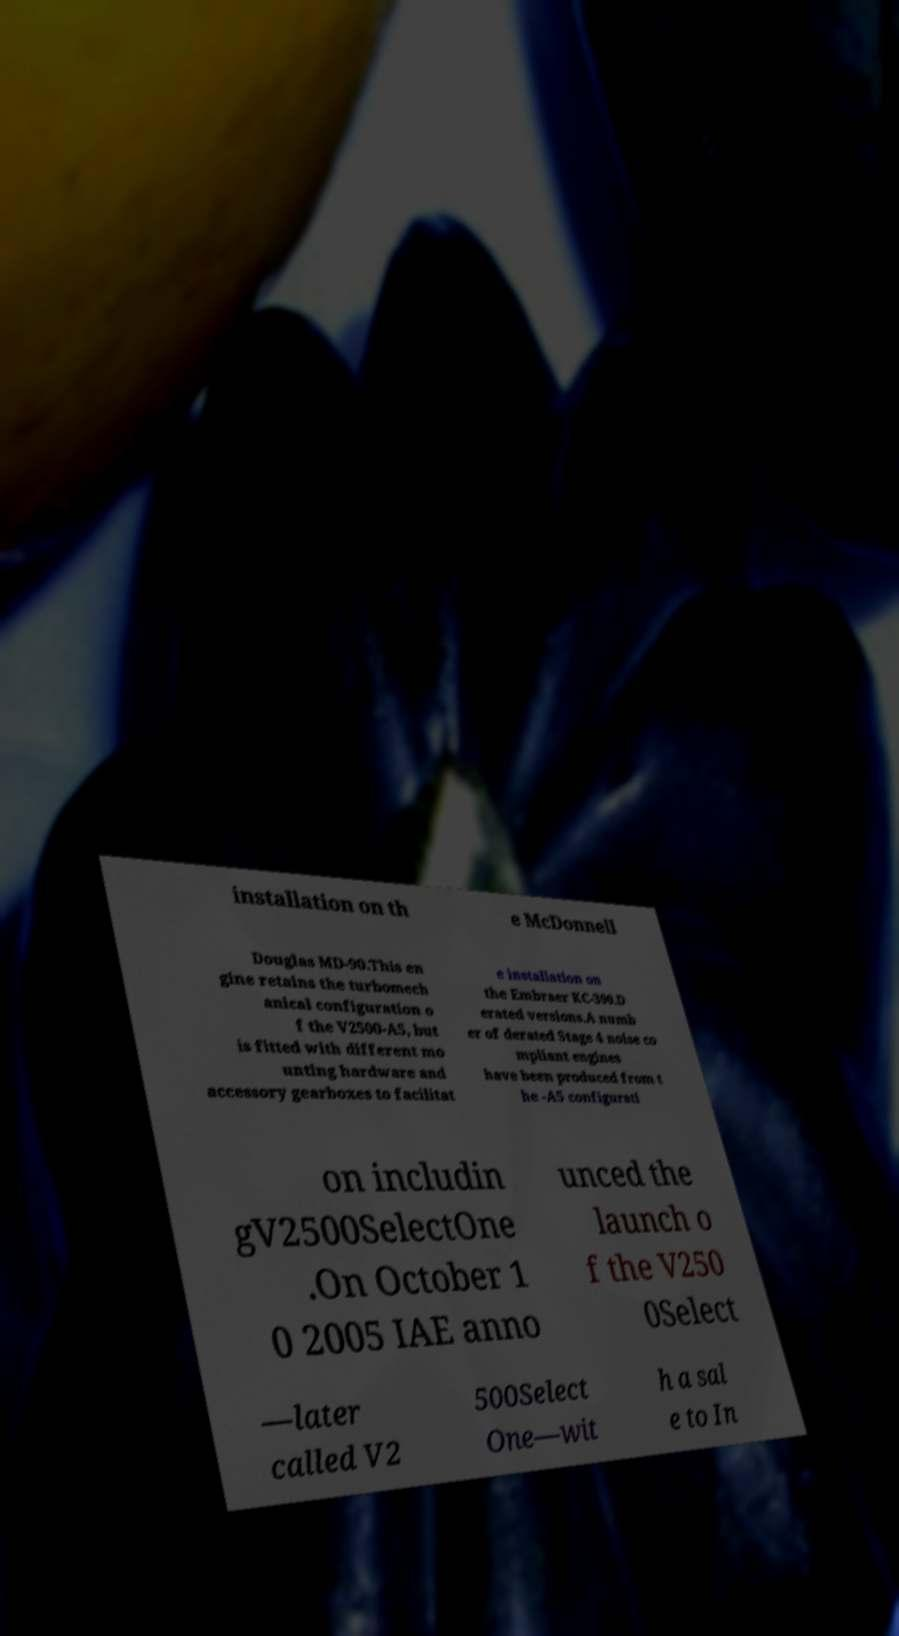There's text embedded in this image that I need extracted. Can you transcribe it verbatim? installation on th e McDonnell Douglas MD-90.This en gine retains the turbomech anical configuration o f the V2500-A5, but is fitted with different mo unting hardware and accessory gearboxes to facilitat e installation on the Embraer KC-390.D erated versions.A numb er of derated Stage 4 noise co mpliant engines have been produced from t he -A5 configurati on includin gV2500SelectOne .On October 1 0 2005 IAE anno unced the launch o f the V250 0Select —later called V2 500Select One—wit h a sal e to In 